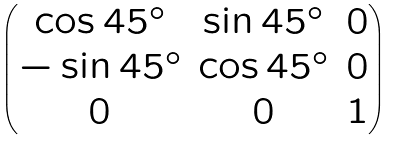Convert formula to latex. <formula><loc_0><loc_0><loc_500><loc_500>\begin{pmatrix} \cos 4 5 ^ { \circ } & \sin 4 5 ^ { \circ } & 0 \\ - \sin 4 5 ^ { \circ } & \cos 4 5 ^ { \circ } & 0 \\ 0 & 0 & 1 \end{pmatrix}</formula> 